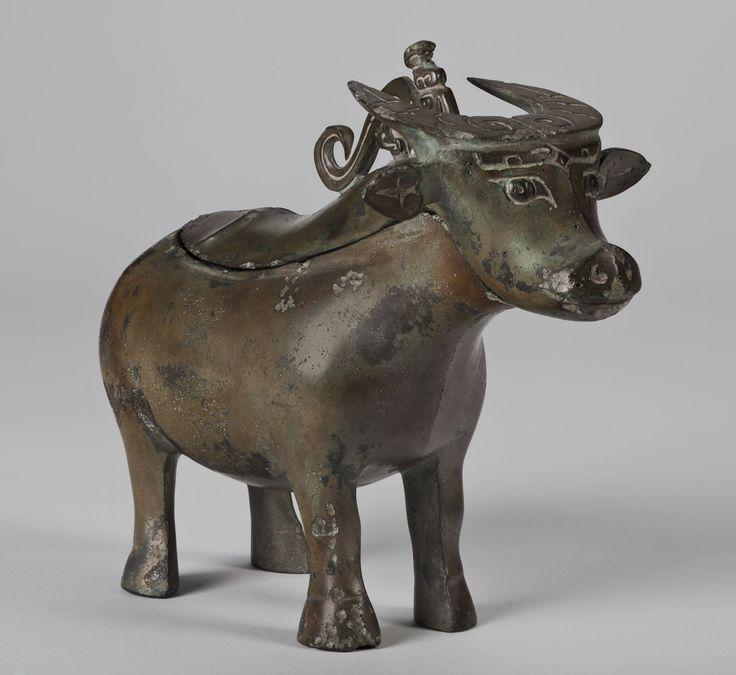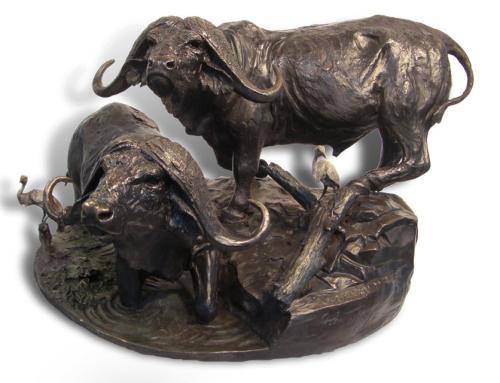The first image is the image on the left, the second image is the image on the right. Examine the images to the left and right. Is the description "Each image shows at least one figure on the back of a water buffalo with its head extending forward so its horns are parallel with the ground." accurate? Answer yes or no. No. The first image is the image on the left, the second image is the image on the right. Given the left and right images, does the statement "There are exactly two animals." hold true? Answer yes or no. No. 